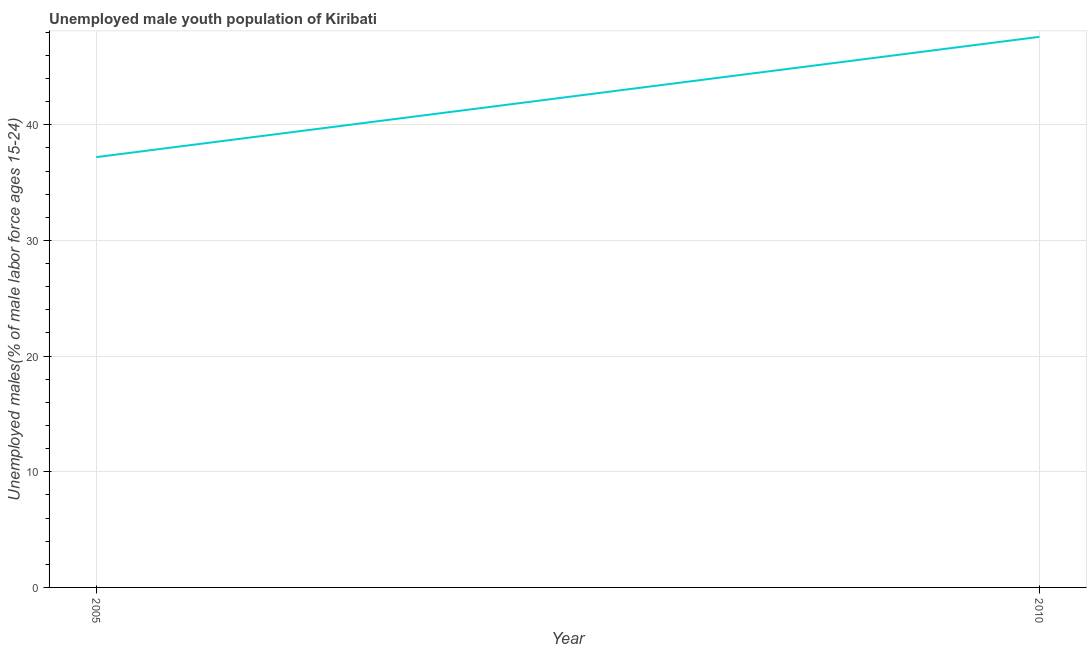What is the unemployed male youth in 2010?
Ensure brevity in your answer.  47.6. Across all years, what is the maximum unemployed male youth?
Make the answer very short. 47.6. Across all years, what is the minimum unemployed male youth?
Give a very brief answer. 37.2. What is the sum of the unemployed male youth?
Your answer should be very brief. 84.8. What is the difference between the unemployed male youth in 2005 and 2010?
Your answer should be compact. -10.4. What is the average unemployed male youth per year?
Provide a short and direct response. 42.4. What is the median unemployed male youth?
Make the answer very short. 42.4. Do a majority of the years between 2010 and 2005 (inclusive) have unemployed male youth greater than 12 %?
Give a very brief answer. No. What is the ratio of the unemployed male youth in 2005 to that in 2010?
Provide a short and direct response. 0.78. What is the difference between two consecutive major ticks on the Y-axis?
Make the answer very short. 10. Does the graph contain any zero values?
Give a very brief answer. No. What is the title of the graph?
Offer a very short reply. Unemployed male youth population of Kiribati. What is the label or title of the Y-axis?
Provide a short and direct response. Unemployed males(% of male labor force ages 15-24). What is the Unemployed males(% of male labor force ages 15-24) of 2005?
Your response must be concise. 37.2. What is the Unemployed males(% of male labor force ages 15-24) in 2010?
Make the answer very short. 47.6. What is the ratio of the Unemployed males(% of male labor force ages 15-24) in 2005 to that in 2010?
Give a very brief answer. 0.78. 